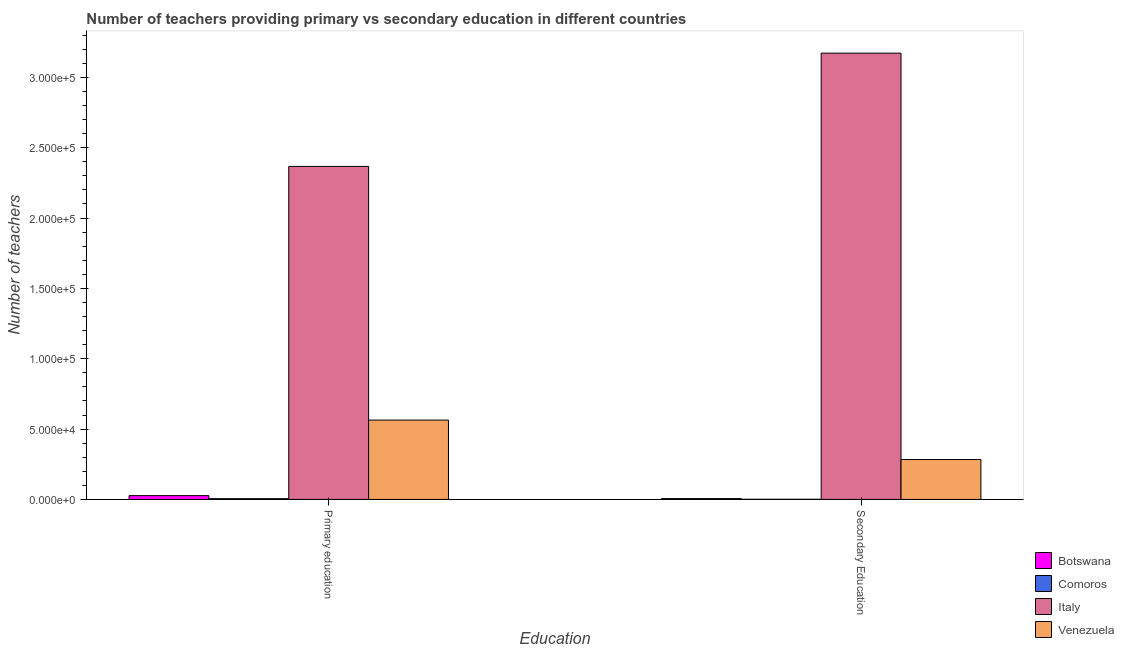How many different coloured bars are there?
Your response must be concise. 4. How many groups of bars are there?
Offer a terse response. 2. Are the number of bars per tick equal to the number of legend labels?
Make the answer very short. Yes. Are the number of bars on each tick of the X-axis equal?
Your answer should be compact. Yes. What is the label of the 2nd group of bars from the left?
Keep it short and to the point. Secondary Education. What is the number of primary teachers in Venezuela?
Provide a succinct answer. 5.64e+04. Across all countries, what is the maximum number of primary teachers?
Your response must be concise. 2.37e+05. Across all countries, what is the minimum number of secondary teachers?
Your response must be concise. 113. In which country was the number of primary teachers maximum?
Give a very brief answer. Italy. In which country was the number of secondary teachers minimum?
Your answer should be very brief. Comoros. What is the total number of secondary teachers in the graph?
Offer a terse response. 3.46e+05. What is the difference between the number of secondary teachers in Botswana and that in Italy?
Provide a succinct answer. -3.17e+05. What is the difference between the number of secondary teachers in Venezuela and the number of primary teachers in Botswana?
Offer a terse response. 2.57e+04. What is the average number of secondary teachers per country?
Provide a short and direct response. 8.66e+04. What is the difference between the number of secondary teachers and number of primary teachers in Botswana?
Make the answer very short. -2101. In how many countries, is the number of primary teachers greater than 240000 ?
Your answer should be compact. 0. What is the ratio of the number of secondary teachers in Botswana to that in Venezuela?
Make the answer very short. 0.02. Is the number of primary teachers in Venezuela less than that in Comoros?
Ensure brevity in your answer.  No. In how many countries, is the number of secondary teachers greater than the average number of secondary teachers taken over all countries?
Give a very brief answer. 1. What does the 1st bar from the left in Primary education represents?
Your response must be concise. Botswana. What does the 2nd bar from the right in Secondary Education represents?
Your answer should be compact. Italy. How many bars are there?
Keep it short and to the point. 8. How many countries are there in the graph?
Your response must be concise. 4. What is the difference between two consecutive major ticks on the Y-axis?
Provide a succinct answer. 5.00e+04. Are the values on the major ticks of Y-axis written in scientific E-notation?
Your answer should be very brief. Yes. Does the graph contain grids?
Your response must be concise. No. What is the title of the graph?
Offer a terse response. Number of teachers providing primary vs secondary education in different countries. What is the label or title of the X-axis?
Keep it short and to the point. Education. What is the label or title of the Y-axis?
Offer a terse response. Number of teachers. What is the Number of teachers of Botswana in Primary education?
Provide a short and direct response. 2698. What is the Number of teachers of Comoros in Primary education?
Keep it short and to the point. 533. What is the Number of teachers in Italy in Primary education?
Give a very brief answer. 2.37e+05. What is the Number of teachers in Venezuela in Primary education?
Your answer should be compact. 5.64e+04. What is the Number of teachers in Botswana in Secondary Education?
Offer a very short reply. 597. What is the Number of teachers in Comoros in Secondary Education?
Your answer should be compact. 113. What is the Number of teachers of Italy in Secondary Education?
Make the answer very short. 3.17e+05. What is the Number of teachers of Venezuela in Secondary Education?
Offer a very short reply. 2.84e+04. Across all Education, what is the maximum Number of teachers of Botswana?
Provide a succinct answer. 2698. Across all Education, what is the maximum Number of teachers of Comoros?
Your response must be concise. 533. Across all Education, what is the maximum Number of teachers of Italy?
Give a very brief answer. 3.17e+05. Across all Education, what is the maximum Number of teachers of Venezuela?
Provide a succinct answer. 5.64e+04. Across all Education, what is the minimum Number of teachers of Botswana?
Provide a short and direct response. 597. Across all Education, what is the minimum Number of teachers in Comoros?
Offer a terse response. 113. Across all Education, what is the minimum Number of teachers of Italy?
Your answer should be very brief. 2.37e+05. Across all Education, what is the minimum Number of teachers of Venezuela?
Your response must be concise. 2.84e+04. What is the total Number of teachers of Botswana in the graph?
Provide a succinct answer. 3295. What is the total Number of teachers in Comoros in the graph?
Your answer should be very brief. 646. What is the total Number of teachers of Italy in the graph?
Offer a terse response. 5.54e+05. What is the total Number of teachers in Venezuela in the graph?
Provide a short and direct response. 8.47e+04. What is the difference between the Number of teachers of Botswana in Primary education and that in Secondary Education?
Offer a very short reply. 2101. What is the difference between the Number of teachers of Comoros in Primary education and that in Secondary Education?
Offer a very short reply. 420. What is the difference between the Number of teachers in Italy in Primary education and that in Secondary Education?
Offer a terse response. -8.05e+04. What is the difference between the Number of teachers of Venezuela in Primary education and that in Secondary Education?
Your answer should be very brief. 2.80e+04. What is the difference between the Number of teachers of Botswana in Primary education and the Number of teachers of Comoros in Secondary Education?
Give a very brief answer. 2585. What is the difference between the Number of teachers of Botswana in Primary education and the Number of teachers of Italy in Secondary Education?
Offer a terse response. -3.14e+05. What is the difference between the Number of teachers of Botswana in Primary education and the Number of teachers of Venezuela in Secondary Education?
Your answer should be compact. -2.57e+04. What is the difference between the Number of teachers in Comoros in Primary education and the Number of teachers in Italy in Secondary Education?
Offer a very short reply. -3.17e+05. What is the difference between the Number of teachers in Comoros in Primary education and the Number of teachers in Venezuela in Secondary Education?
Ensure brevity in your answer.  -2.78e+04. What is the difference between the Number of teachers of Italy in Primary education and the Number of teachers of Venezuela in Secondary Education?
Offer a terse response. 2.08e+05. What is the average Number of teachers of Botswana per Education?
Ensure brevity in your answer.  1647.5. What is the average Number of teachers in Comoros per Education?
Your answer should be very brief. 323. What is the average Number of teachers of Italy per Education?
Ensure brevity in your answer.  2.77e+05. What is the average Number of teachers in Venezuela per Education?
Provide a short and direct response. 4.24e+04. What is the difference between the Number of teachers in Botswana and Number of teachers in Comoros in Primary education?
Offer a very short reply. 2165. What is the difference between the Number of teachers of Botswana and Number of teachers of Italy in Primary education?
Offer a very short reply. -2.34e+05. What is the difference between the Number of teachers of Botswana and Number of teachers of Venezuela in Primary education?
Offer a terse response. -5.37e+04. What is the difference between the Number of teachers in Comoros and Number of teachers in Italy in Primary education?
Your answer should be very brief. -2.36e+05. What is the difference between the Number of teachers of Comoros and Number of teachers of Venezuela in Primary education?
Offer a terse response. -5.59e+04. What is the difference between the Number of teachers of Italy and Number of teachers of Venezuela in Primary education?
Your response must be concise. 1.80e+05. What is the difference between the Number of teachers in Botswana and Number of teachers in Comoros in Secondary Education?
Your answer should be compact. 484. What is the difference between the Number of teachers of Botswana and Number of teachers of Italy in Secondary Education?
Make the answer very short. -3.17e+05. What is the difference between the Number of teachers in Botswana and Number of teachers in Venezuela in Secondary Education?
Provide a short and direct response. -2.78e+04. What is the difference between the Number of teachers of Comoros and Number of teachers of Italy in Secondary Education?
Offer a terse response. -3.17e+05. What is the difference between the Number of teachers of Comoros and Number of teachers of Venezuela in Secondary Education?
Keep it short and to the point. -2.82e+04. What is the difference between the Number of teachers of Italy and Number of teachers of Venezuela in Secondary Education?
Your answer should be compact. 2.89e+05. What is the ratio of the Number of teachers of Botswana in Primary education to that in Secondary Education?
Your response must be concise. 4.52. What is the ratio of the Number of teachers in Comoros in Primary education to that in Secondary Education?
Ensure brevity in your answer.  4.72. What is the ratio of the Number of teachers of Italy in Primary education to that in Secondary Education?
Give a very brief answer. 0.75. What is the ratio of the Number of teachers of Venezuela in Primary education to that in Secondary Education?
Provide a succinct answer. 1.99. What is the difference between the highest and the second highest Number of teachers of Botswana?
Provide a succinct answer. 2101. What is the difference between the highest and the second highest Number of teachers of Comoros?
Your answer should be very brief. 420. What is the difference between the highest and the second highest Number of teachers in Italy?
Ensure brevity in your answer.  8.05e+04. What is the difference between the highest and the second highest Number of teachers in Venezuela?
Keep it short and to the point. 2.80e+04. What is the difference between the highest and the lowest Number of teachers in Botswana?
Your response must be concise. 2101. What is the difference between the highest and the lowest Number of teachers of Comoros?
Your answer should be compact. 420. What is the difference between the highest and the lowest Number of teachers in Italy?
Make the answer very short. 8.05e+04. What is the difference between the highest and the lowest Number of teachers in Venezuela?
Ensure brevity in your answer.  2.80e+04. 